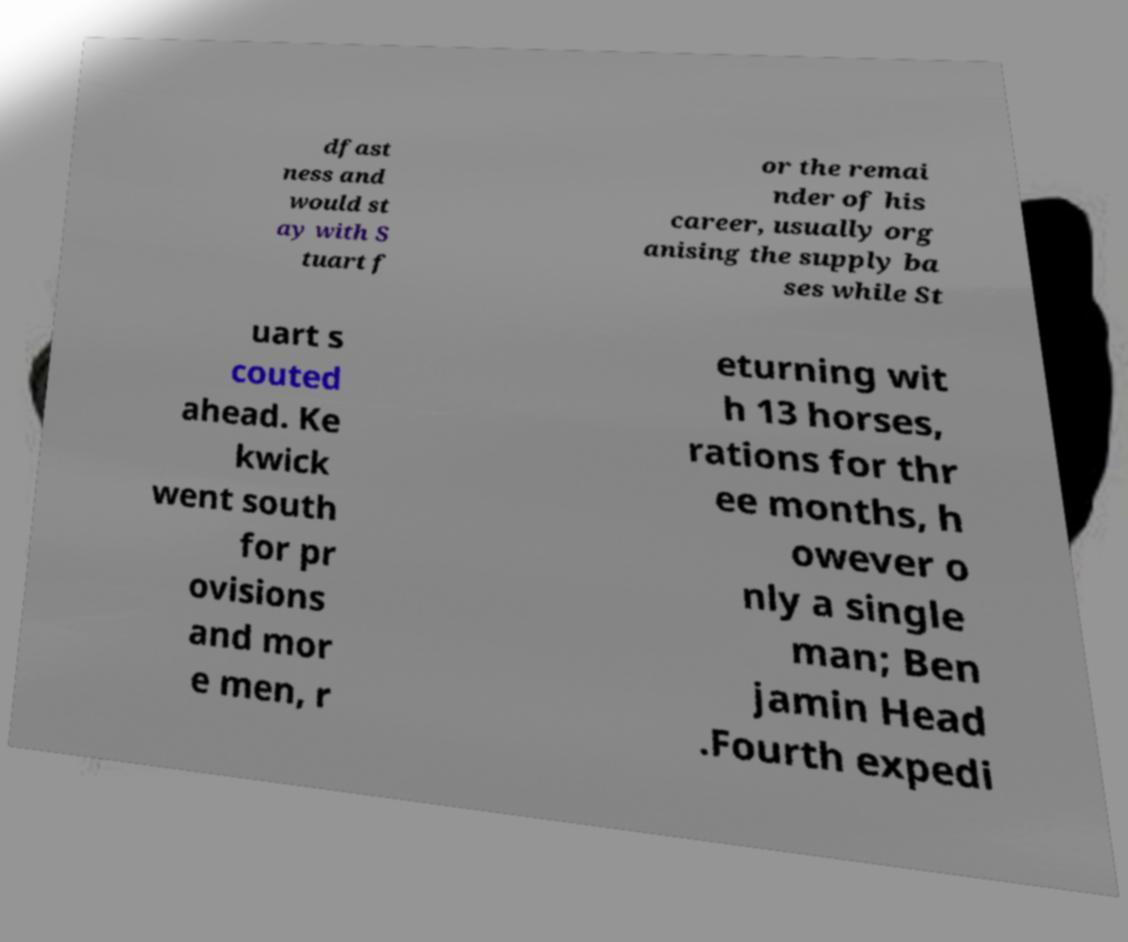Can you accurately transcribe the text from the provided image for me? dfast ness and would st ay with S tuart f or the remai nder of his career, usually org anising the supply ba ses while St uart s couted ahead. Ke kwick went south for pr ovisions and mor e men, r eturning wit h 13 horses, rations for thr ee months, h owever o nly a single man; Ben jamin Head .Fourth expedi 